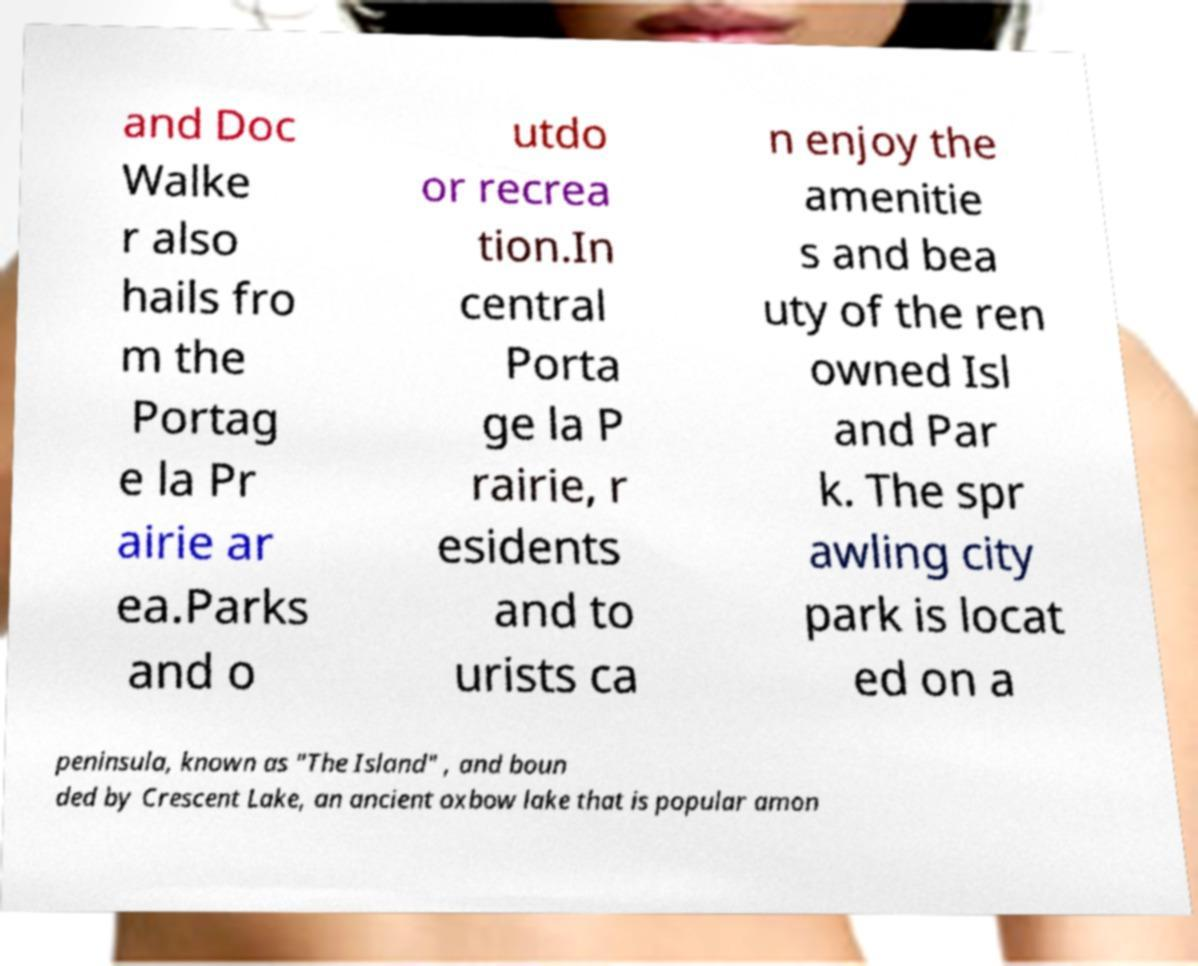Can you read and provide the text displayed in the image?This photo seems to have some interesting text. Can you extract and type it out for me? and Doc Walke r also hails fro m the Portag e la Pr airie ar ea.Parks and o utdo or recrea tion.In central Porta ge la P rairie, r esidents and to urists ca n enjoy the amenitie s and bea uty of the ren owned Isl and Par k. The spr awling city park is locat ed on a peninsula, known as "The Island" , and boun ded by Crescent Lake, an ancient oxbow lake that is popular amon 